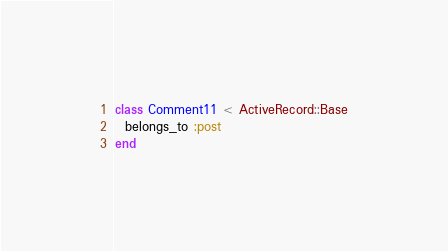<code> <loc_0><loc_0><loc_500><loc_500><_Ruby_>class Comment11 < ActiveRecord::Base
  belongs_to :post
end
</code> 